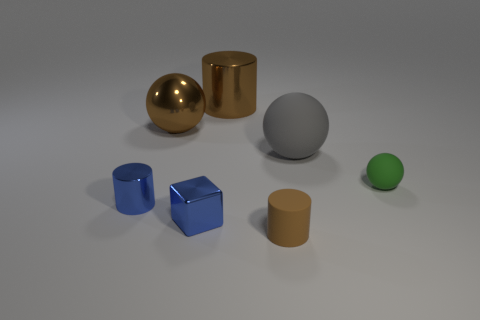Subtract all tiny brown matte cylinders. How many cylinders are left? 2 Subtract all red blocks. How many brown cylinders are left? 2 Add 1 big red rubber objects. How many objects exist? 8 Subtract 1 cylinders. How many cylinders are left? 2 Subtract all green cylinders. Subtract all blue balls. How many cylinders are left? 3 Add 3 small cyan cylinders. How many small cyan cylinders exist? 3 Subtract 1 blue cylinders. How many objects are left? 6 Subtract all cylinders. How many objects are left? 4 Subtract all large brown shiny objects. Subtract all big metal balls. How many objects are left? 4 Add 2 big metal balls. How many big metal balls are left? 3 